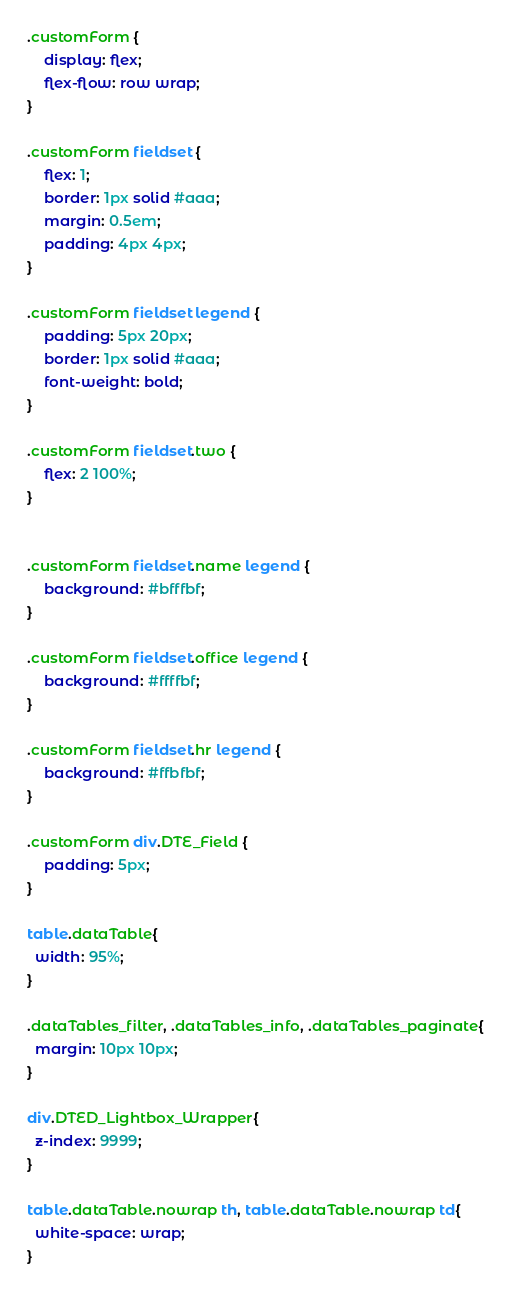<code> <loc_0><loc_0><loc_500><loc_500><_CSS_>.customForm {
    display: flex;
    flex-flow: row wrap;
}

.customForm fieldset {
    flex: 1;
    border: 1px solid #aaa;
    margin: 0.5em;
    padding: 4px 4px;
}

.customForm fieldset legend {
    padding: 5px 20px;
    border: 1px solid #aaa;
    font-weight: bold;
}

.customForm fieldset.two {
    flex: 2 100%;
}


.customForm fieldset.name legend {
    background: #bfffbf;
}

.customForm fieldset.office legend {
    background: #ffffbf;
}

.customForm fieldset.hr legend {
    background: #ffbfbf;
}

.customForm div.DTE_Field {
    padding: 5px;
}

table.dataTable{
  width: 95%;
}

.dataTables_filter, .dataTables_info, .dataTables_paginate{
  margin: 10px 10px;
}

div.DTED_Lightbox_Wrapper{
  z-index: 9999;
}

table.dataTable.nowrap th, table.dataTable.nowrap td{
  white-space: wrap;
}
</code> 